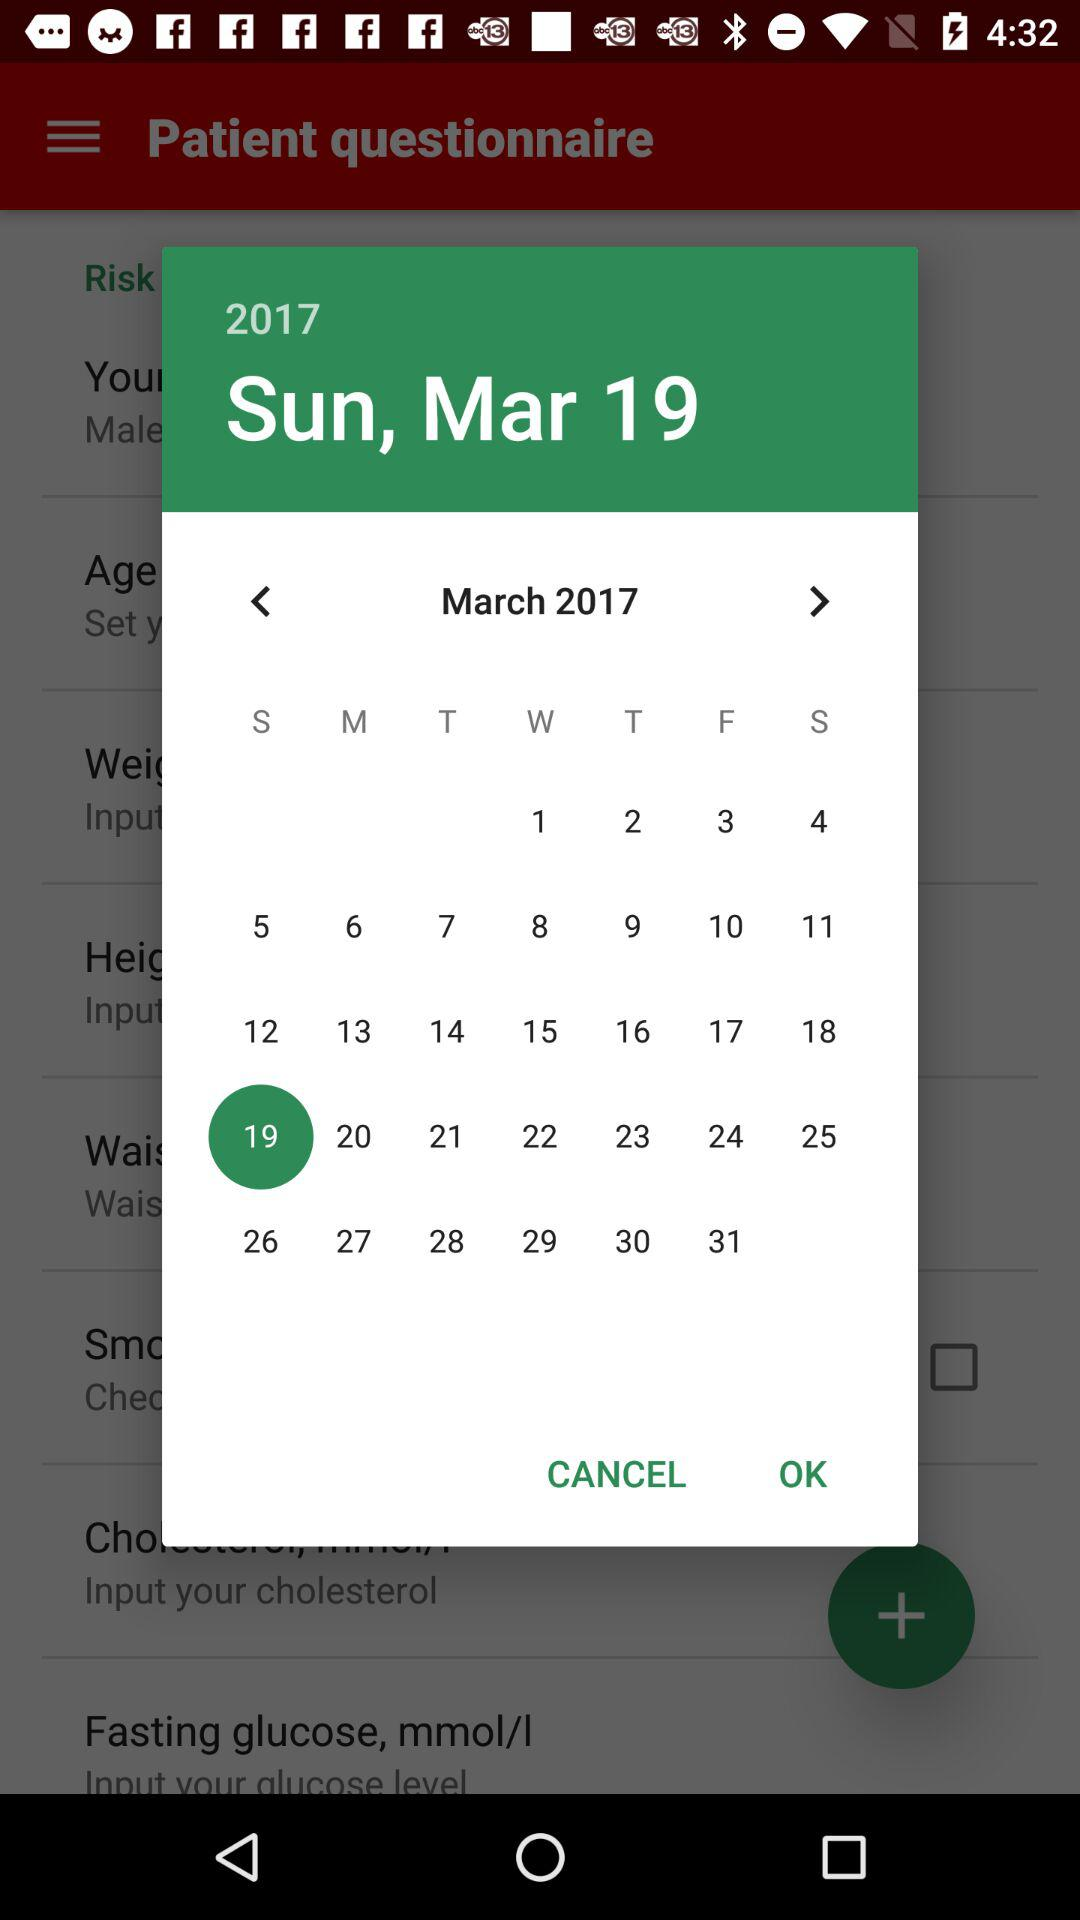What is the selected date? The selected date is Sunday, March 19, 2017. 